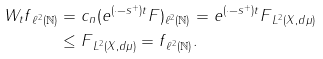Convert formula to latex. <formula><loc_0><loc_0><loc_500><loc_500>\| W _ { t } f \| _ { \ell ^ { 2 } ( \mathbb { N } ) } & = \| c _ { n } ( e ^ { ( \cdot - s ^ { + } ) t } F ) \| _ { \ell ^ { 2 } ( \mathbb { N } ) } = \| e ^ { ( \cdot - s ^ { + } ) t } F \| _ { L ^ { 2 } ( X , d \mu ) } \\ & \leq \| F \| _ { L ^ { 2 } ( X , d \mu ) } = \| f \| _ { \ell ^ { 2 } ( \mathbb { N } ) } .</formula> 